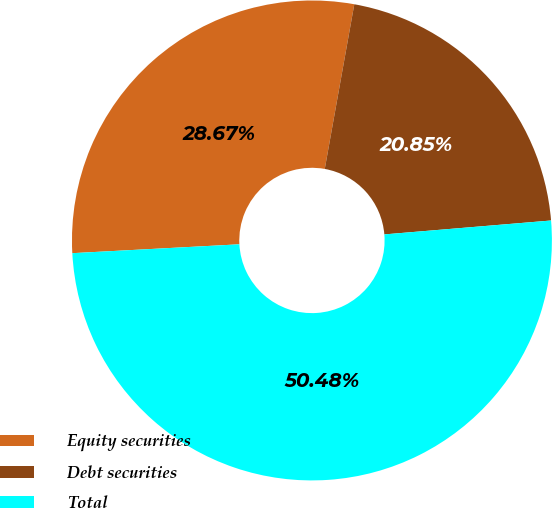Convert chart. <chart><loc_0><loc_0><loc_500><loc_500><pie_chart><fcel>Equity securities<fcel>Debt securities<fcel>Total<nl><fcel>28.67%<fcel>20.85%<fcel>50.48%<nl></chart> 